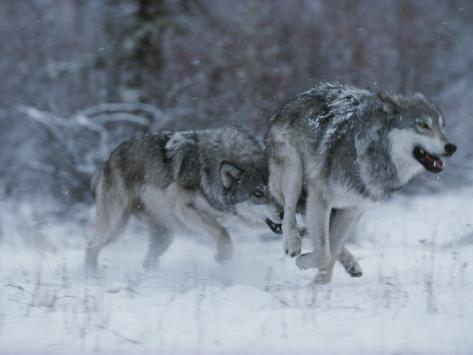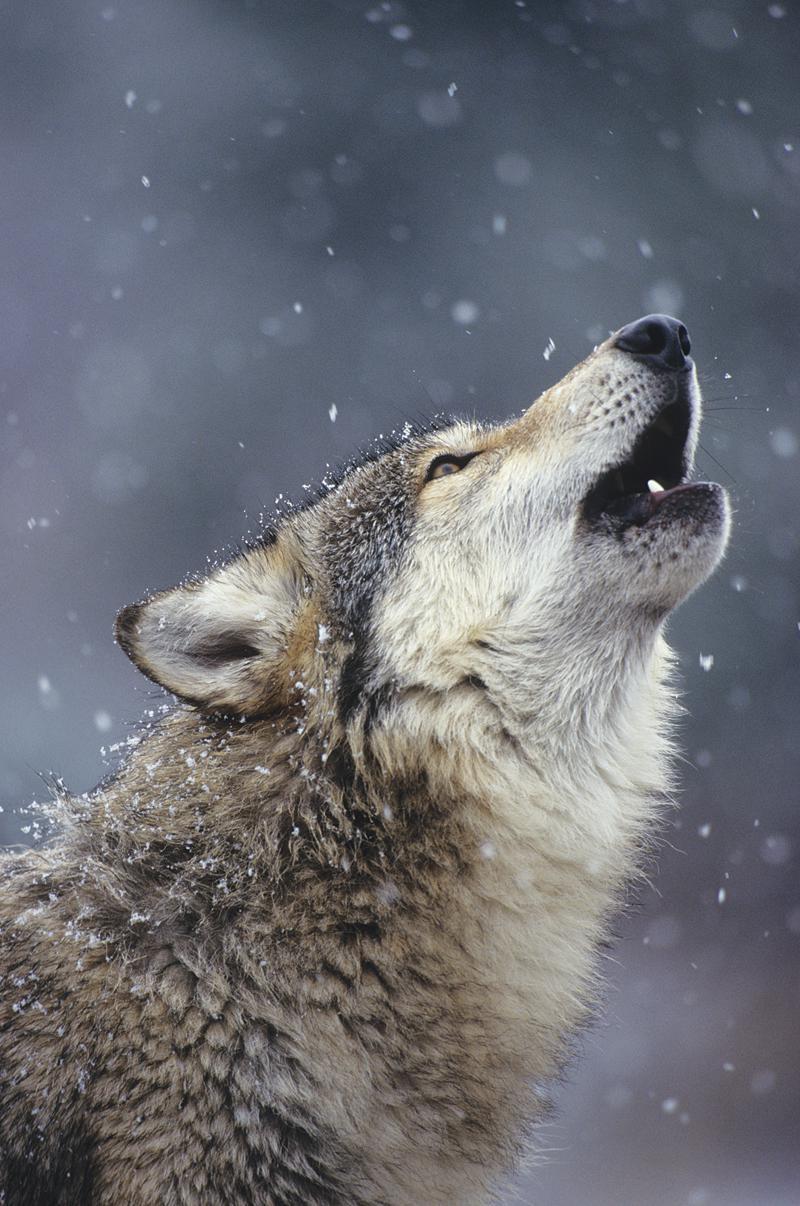The first image is the image on the left, the second image is the image on the right. Examine the images to the left and right. Is the description "There is a single white wolf in each of the images." accurate? Answer yes or no. No. The first image is the image on the left, the second image is the image on the right. For the images displayed, is the sentence "A dog has its mouth open." factually correct? Answer yes or no. Yes. 